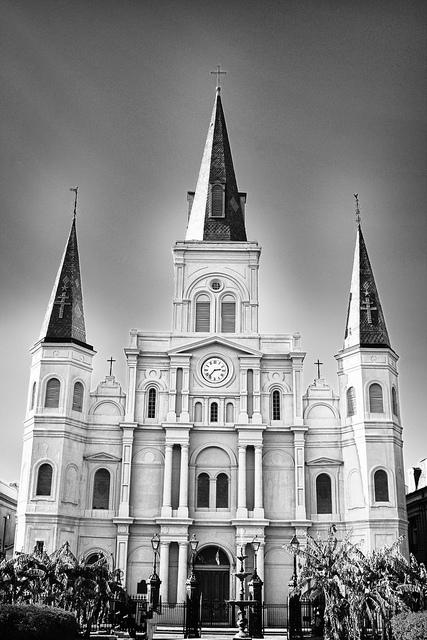Would a person seem small in this building?
Concise answer only. Yes. Where is the clock?
Be succinct. On building. Is this a modern home?
Concise answer only. No. 